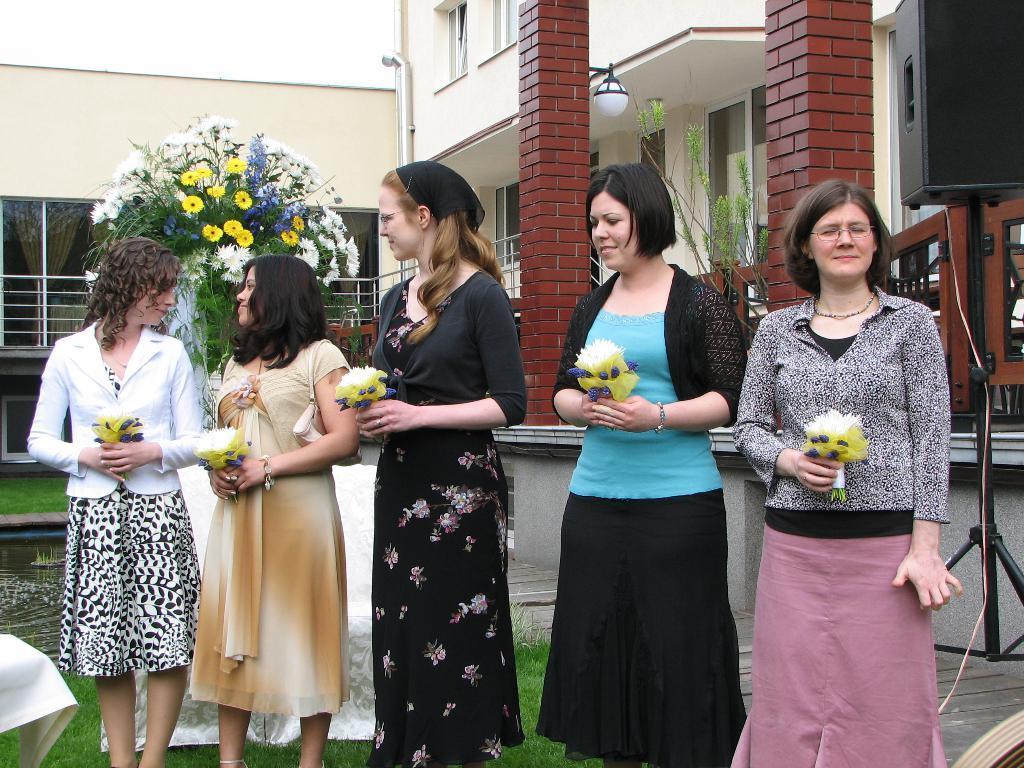Could you give a brief overview of what you see in this image? This image consists of five women holding flowers and standing. At the bottom, there is green grass. In the background, there is a plant along with the flowers. On the right, there is a speaker. And we can see a building along with the pillars. 